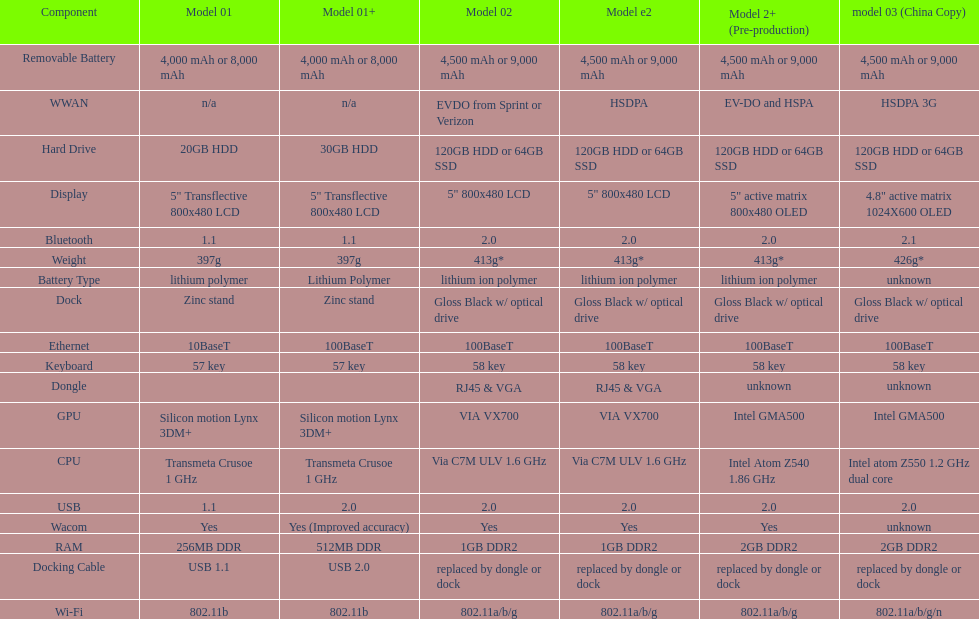Which model provides a larger hard drive: model 01 or model 02? Model 02. Parse the table in full. {'header': ['Component', 'Model 01', 'Model 01+', 'Model 02', 'Model e2', 'Model 2+ (Pre-production)', 'model 03 (China Copy)'], 'rows': [['Removable Battery', '4,000 mAh or 8,000 mAh', '4,000 mAh or 8,000 mAh', '4,500 mAh or 9,000 mAh', '4,500 mAh or 9,000 mAh', '4,500 mAh or 9,000 mAh', '4,500 mAh or 9,000 mAh'], ['WWAN', 'n/a', 'n/a', 'EVDO from Sprint or Verizon', 'HSDPA', 'EV-DO and HSPA', 'HSDPA 3G'], ['Hard Drive', '20GB HDD', '30GB HDD', '120GB HDD or 64GB SSD', '120GB HDD or 64GB SSD', '120GB HDD or 64GB SSD', '120GB HDD or 64GB SSD'], ['Display', '5" Transflective 800x480 LCD', '5" Transflective 800x480 LCD', '5" 800x480 LCD', '5" 800x480 LCD', '5" active matrix 800x480 OLED', '4.8" active matrix 1024X600 OLED'], ['Bluetooth', '1.1', '1.1', '2.0', '2.0', '2.0', '2.1'], ['Weight', '397g', '397g', '413g*', '413g*', '413g*', '426g*'], ['Battery Type', 'lithium polymer', 'Lithium Polymer', 'lithium ion polymer', 'lithium ion polymer', 'lithium ion polymer', 'unknown'], ['Dock', 'Zinc stand', 'Zinc stand', 'Gloss Black w/ optical drive', 'Gloss Black w/ optical drive', 'Gloss Black w/ optical drive', 'Gloss Black w/ optical drive'], ['Ethernet', '10BaseT', '100BaseT', '100BaseT', '100BaseT', '100BaseT', '100BaseT'], ['Keyboard', '57 key', '57 key', '58 key', '58 key', '58 key', '58 key'], ['Dongle', '', '', 'RJ45 & VGA', 'RJ45 & VGA', 'unknown', 'unknown'], ['GPU', 'Silicon motion Lynx 3DM+', 'Silicon motion Lynx 3DM+', 'VIA VX700', 'VIA VX700', 'Intel GMA500', 'Intel GMA500'], ['CPU', 'Transmeta Crusoe 1\xa0GHz', 'Transmeta Crusoe 1\xa0GHz', 'Via C7M ULV 1.6\xa0GHz', 'Via C7M ULV 1.6\xa0GHz', 'Intel Atom Z540 1.86\xa0GHz', 'Intel atom Z550 1.2\xa0GHz dual core'], ['USB', '1.1', '2.0', '2.0', '2.0', '2.0', '2.0'], ['Wacom', 'Yes', 'Yes (Improved accuracy)', 'Yes', 'Yes', 'Yes', 'unknown'], ['RAM', '256MB DDR', '512MB DDR', '1GB DDR2', '1GB DDR2', '2GB DDR2', '2GB DDR2'], ['Docking Cable', 'USB 1.1', 'USB 2.0', 'replaced by dongle or dock', 'replaced by dongle or dock', 'replaced by dongle or dock', 'replaced by dongle or dock'], ['Wi-Fi', '802.11b', '802.11b', '802.11a/b/g', '802.11a/b/g', '802.11a/b/g', '802.11a/b/g/n']]} 